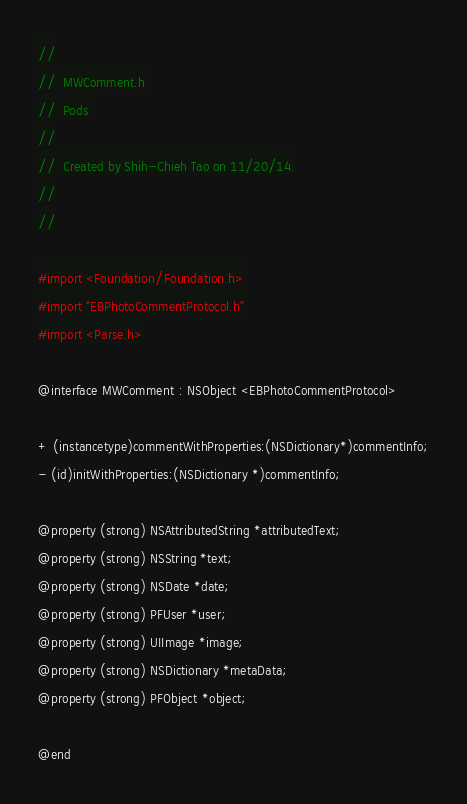Convert code to text. <code><loc_0><loc_0><loc_500><loc_500><_C_>//
//  MWComment.h
//  Pods
//
//  Created by Shih-Chieh Tao on 11/20/14.
//
//

#import <Foundation/Foundation.h>
#import "EBPhotoCommentProtocol.h"
#import <Parse.h>

@interface MWComment : NSObject <EBPhotoCommentProtocol>

+ (instancetype)commentWithProperties:(NSDictionary*)commentInfo;
- (id)initWithProperties:(NSDictionary *)commentInfo;

@property (strong) NSAttributedString *attributedText;
@property (strong) NSString *text;
@property (strong) NSDate *date;
@property (strong) PFUser *user;
@property (strong) UIImage *image;
@property (strong) NSDictionary *metaData;
@property (strong) PFObject *object;

@end
</code> 